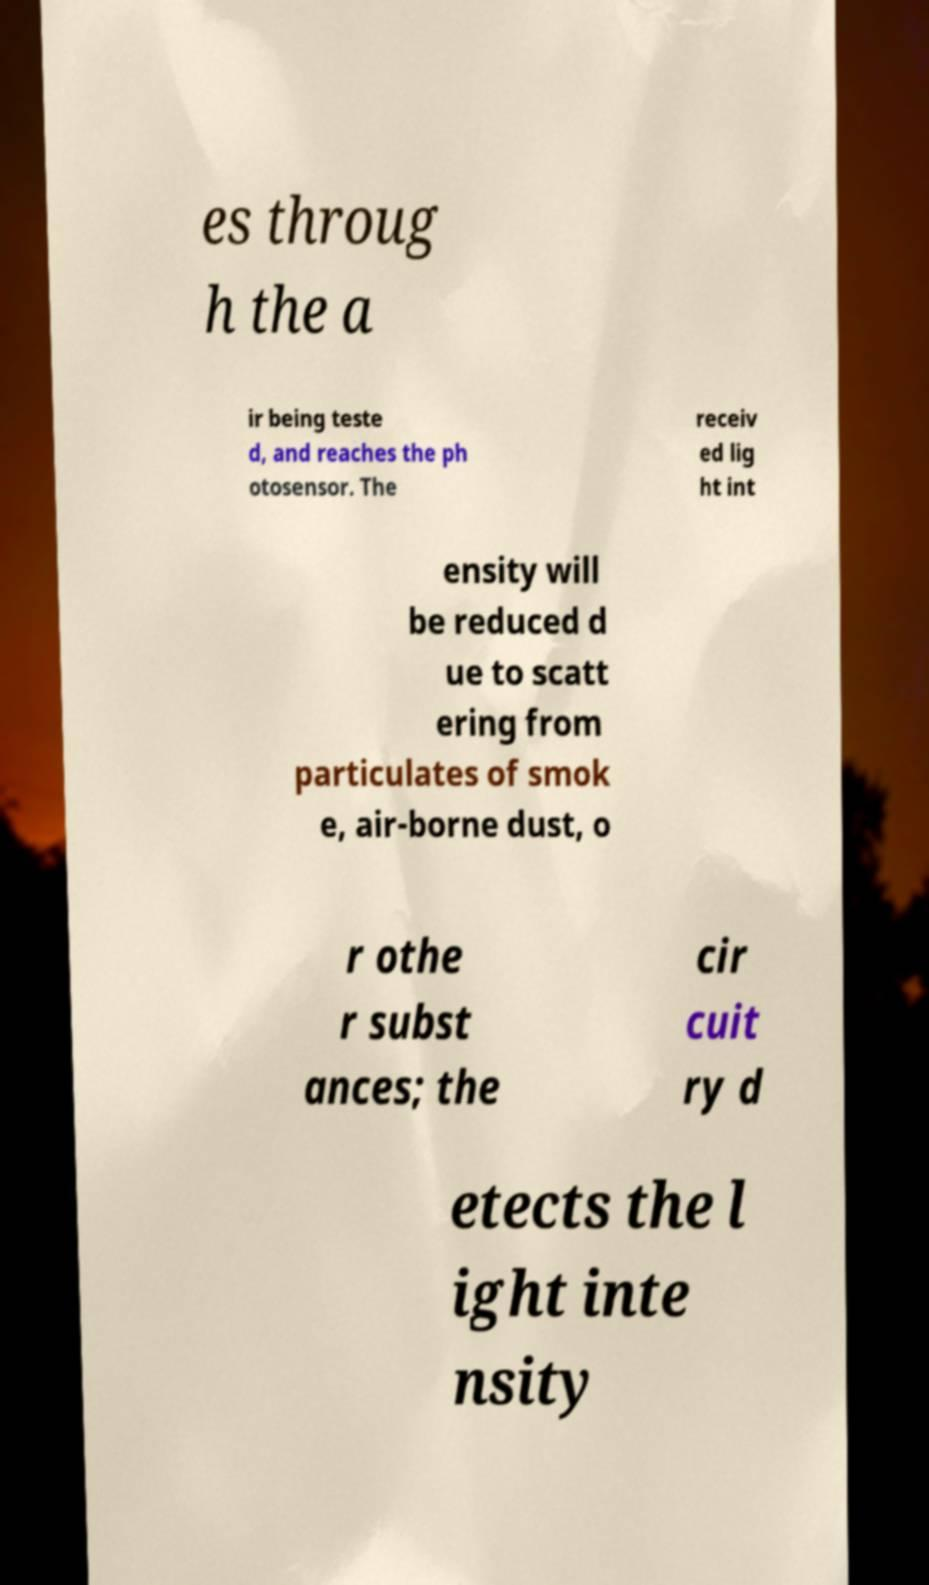Could you assist in decoding the text presented in this image and type it out clearly? es throug h the a ir being teste d, and reaches the ph otosensor. The receiv ed lig ht int ensity will be reduced d ue to scatt ering from particulates of smok e, air-borne dust, o r othe r subst ances; the cir cuit ry d etects the l ight inte nsity 